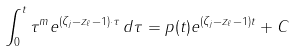<formula> <loc_0><loc_0><loc_500><loc_500>\int _ { 0 } ^ { t } \tau ^ { m } e ^ { ( \zeta _ { j } - z _ { \ell } - 1 ) \cdot \tau } \, d \tau = p ( t ) e ^ { ( \zeta _ { j } - z _ { \ell } - 1 ) t } + C</formula> 